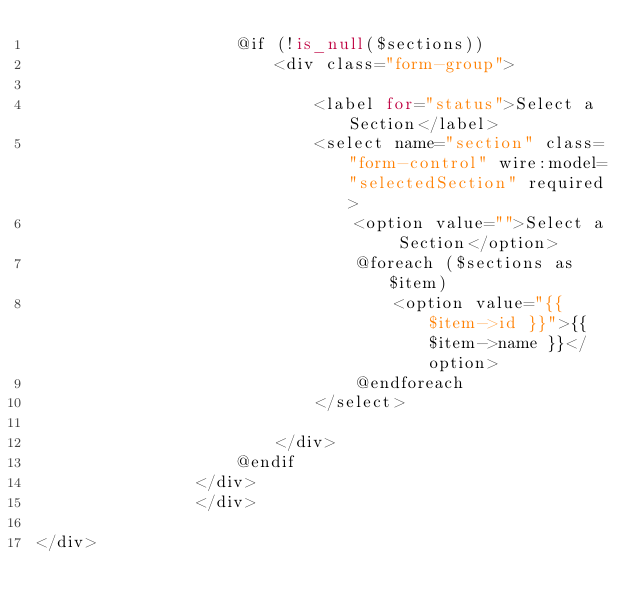Convert code to text. <code><loc_0><loc_0><loc_500><loc_500><_PHP_>                    @if (!is_null($sections))
                        <div class="form-group">

                            <label for="status">Select a Section</label>
                            <select name="section" class="form-control" wire:model="selectedSection" required>
                                <option value="">Select a Section</option>
                                @foreach ($sections as $item)
                                    <option value="{{ $item->id }}">{{ $item->name }}</option>
                                @endforeach
                            </select>

                        </div>
                    @endif
                </div>
                </div>

</div>
</code> 